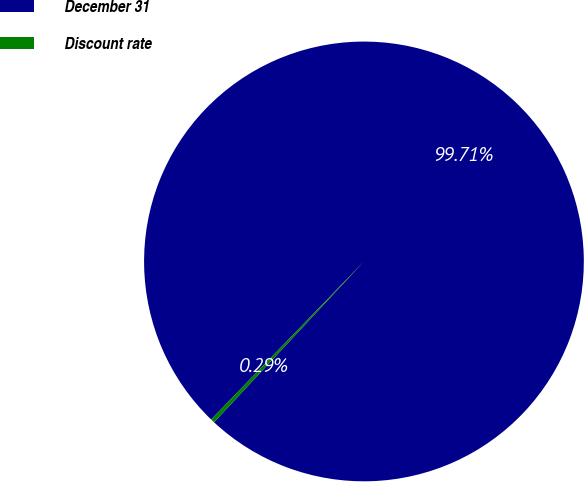Convert chart. <chart><loc_0><loc_0><loc_500><loc_500><pie_chart><fcel>December 31<fcel>Discount rate<nl><fcel>99.71%<fcel>0.29%<nl></chart> 